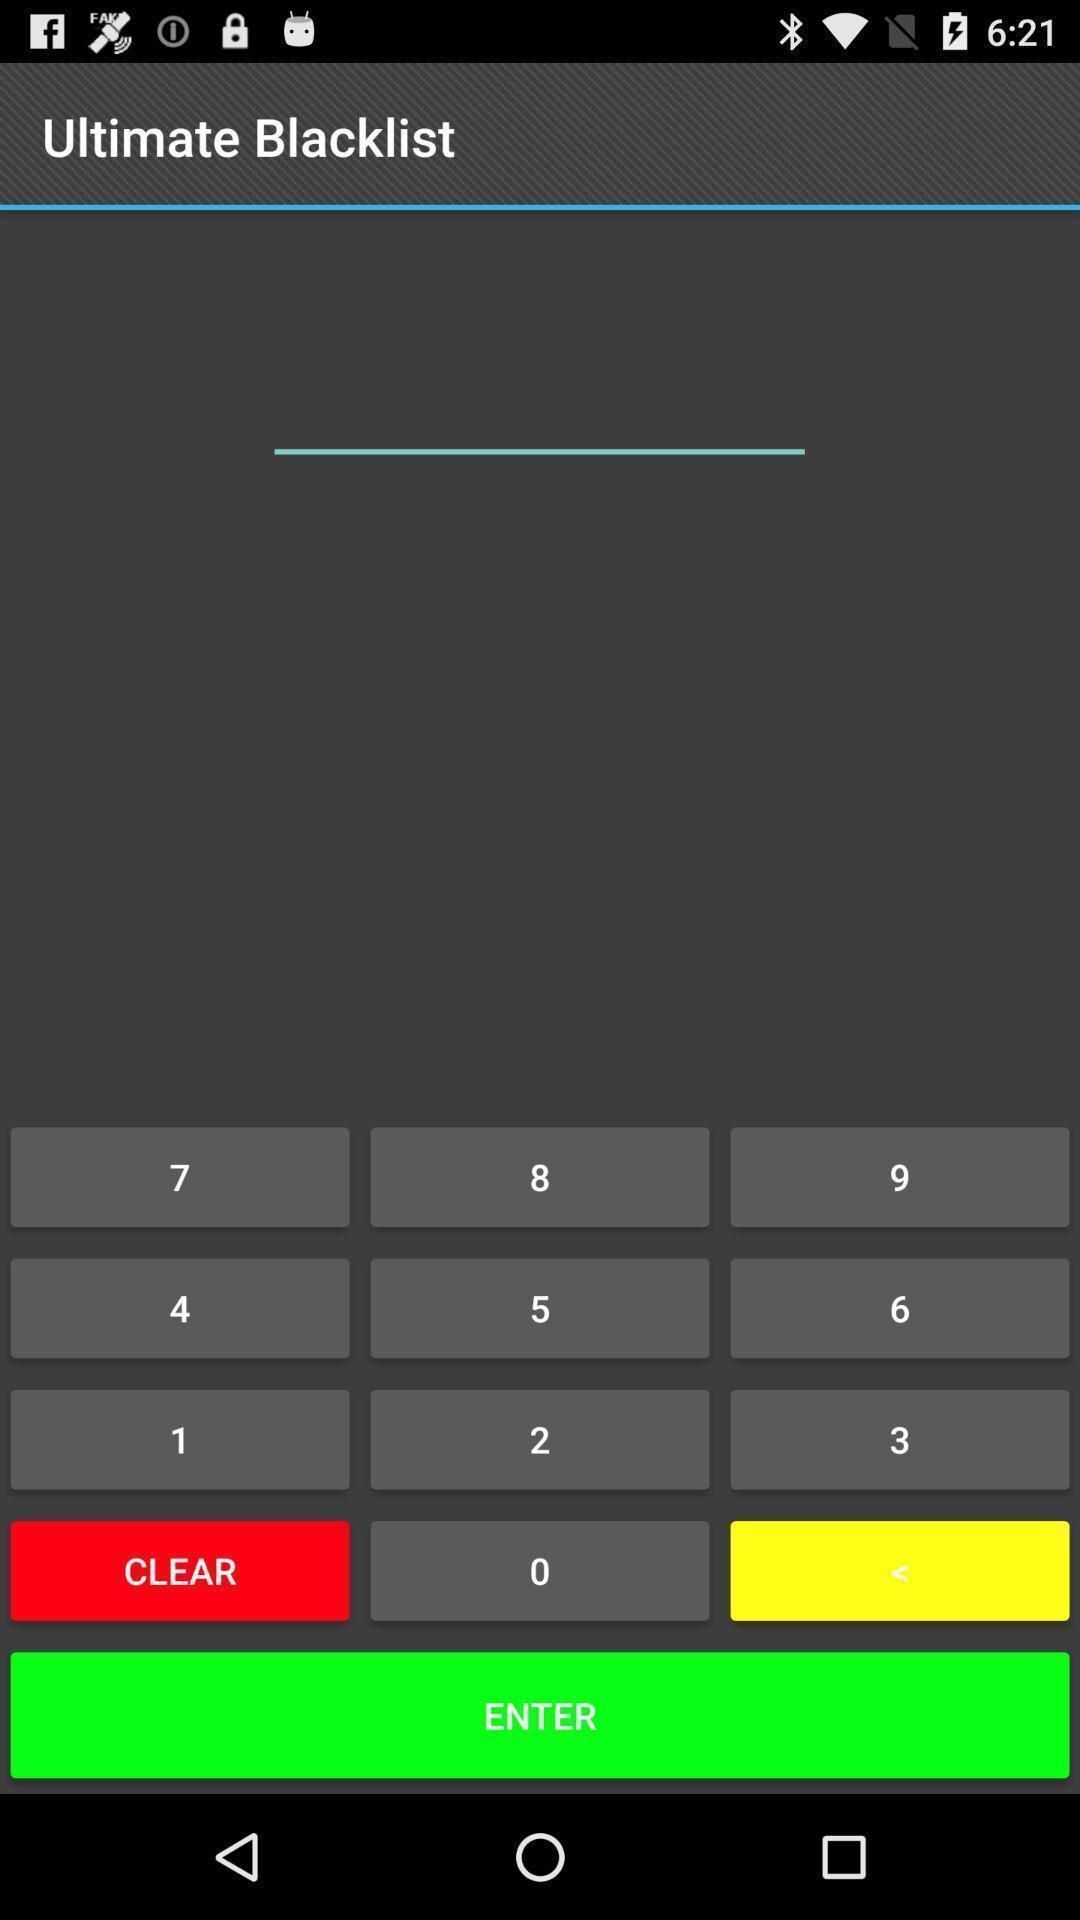Tell me about the visual elements in this screen capture. Page displaying with keypad and with few options. 